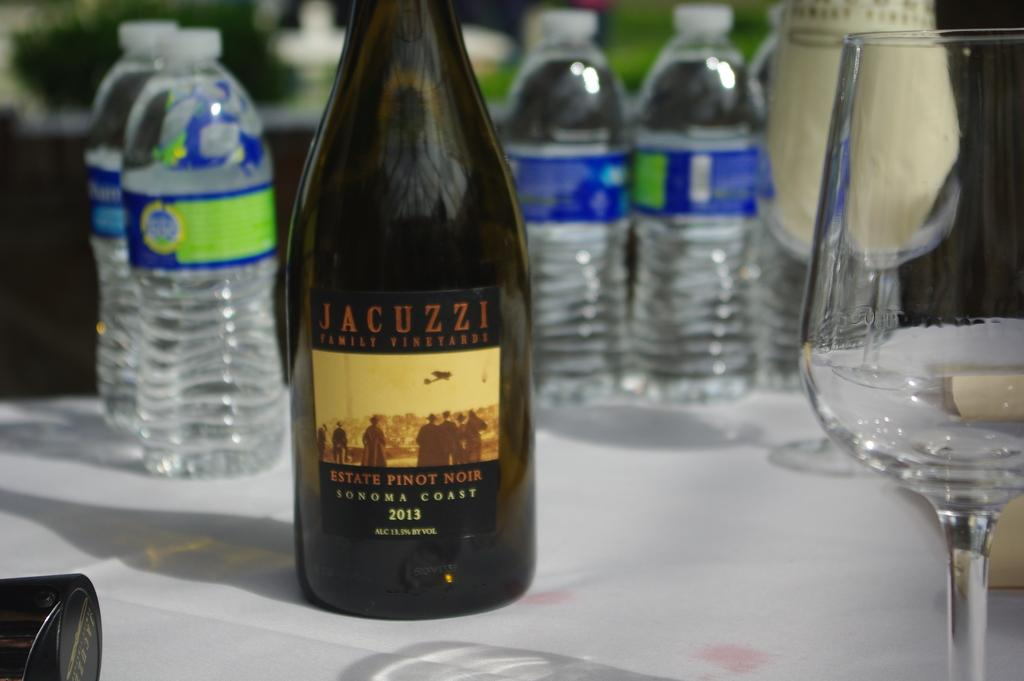<image>
Offer a succinct explanation of the picture presented. the word jacuzzi that is on a wine bottle 